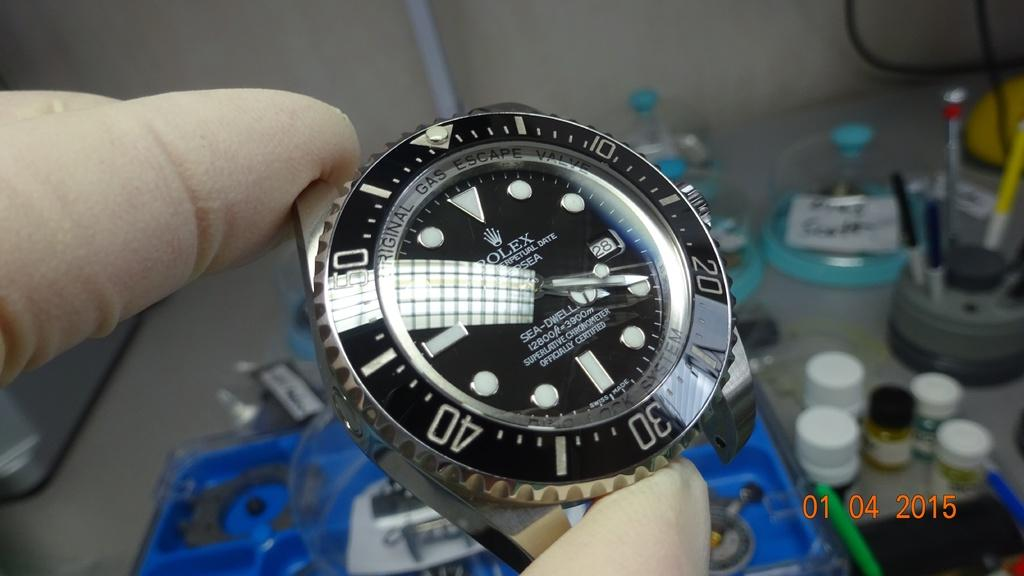Provide a one-sentence caption for the provided image. A photo of a bandless watch that was taken in January of 2015. 